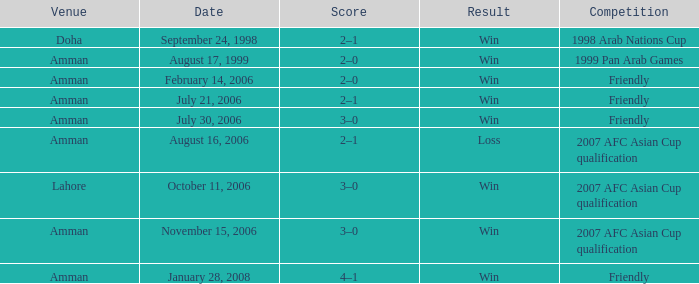Which competition took place on October 11, 2006? 2007 AFC Asian Cup qualification. 